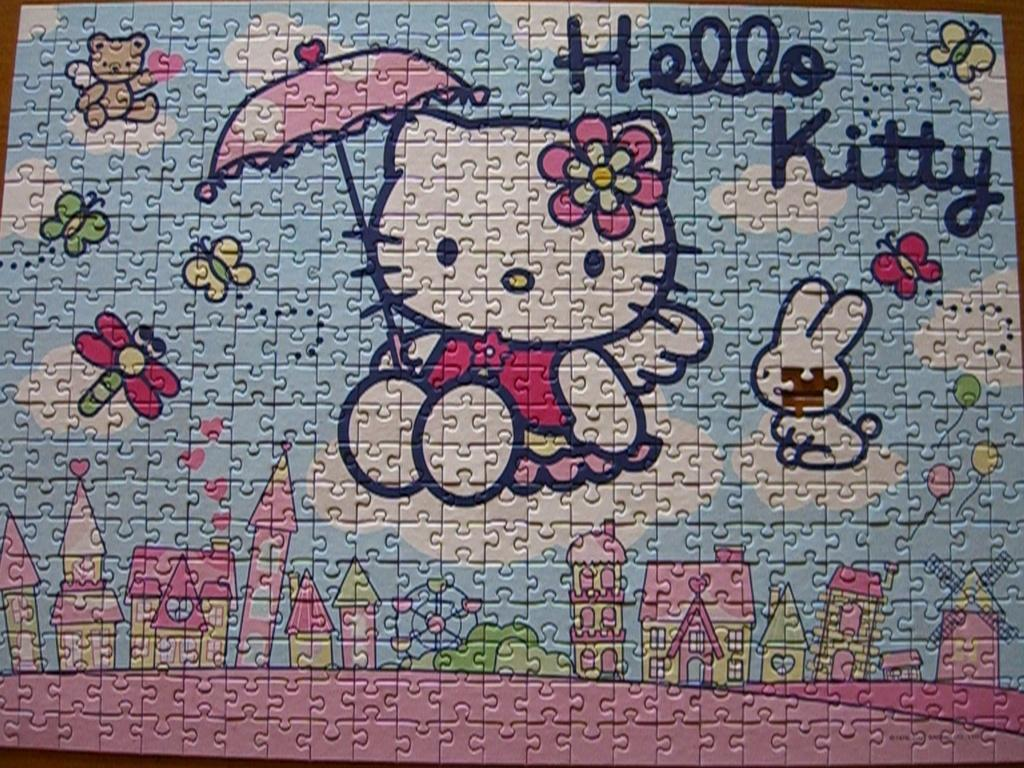What type of game is featured in the image? There is a puzzle game in the image. What subjects are depicted on the puzzle game? The puzzle game contains pictures of dolls, insects, and buildings. Is there any text visible on the puzzle game? Yes, there is text visible on the puzzle game. Can you see any kittens playing with a sock in the image? No, there are no kittens or socks present in the image. How many planes are visible in the image? There are no planes visible in the image; it features a puzzle game with pictures of dolls, insects, and buildings. 